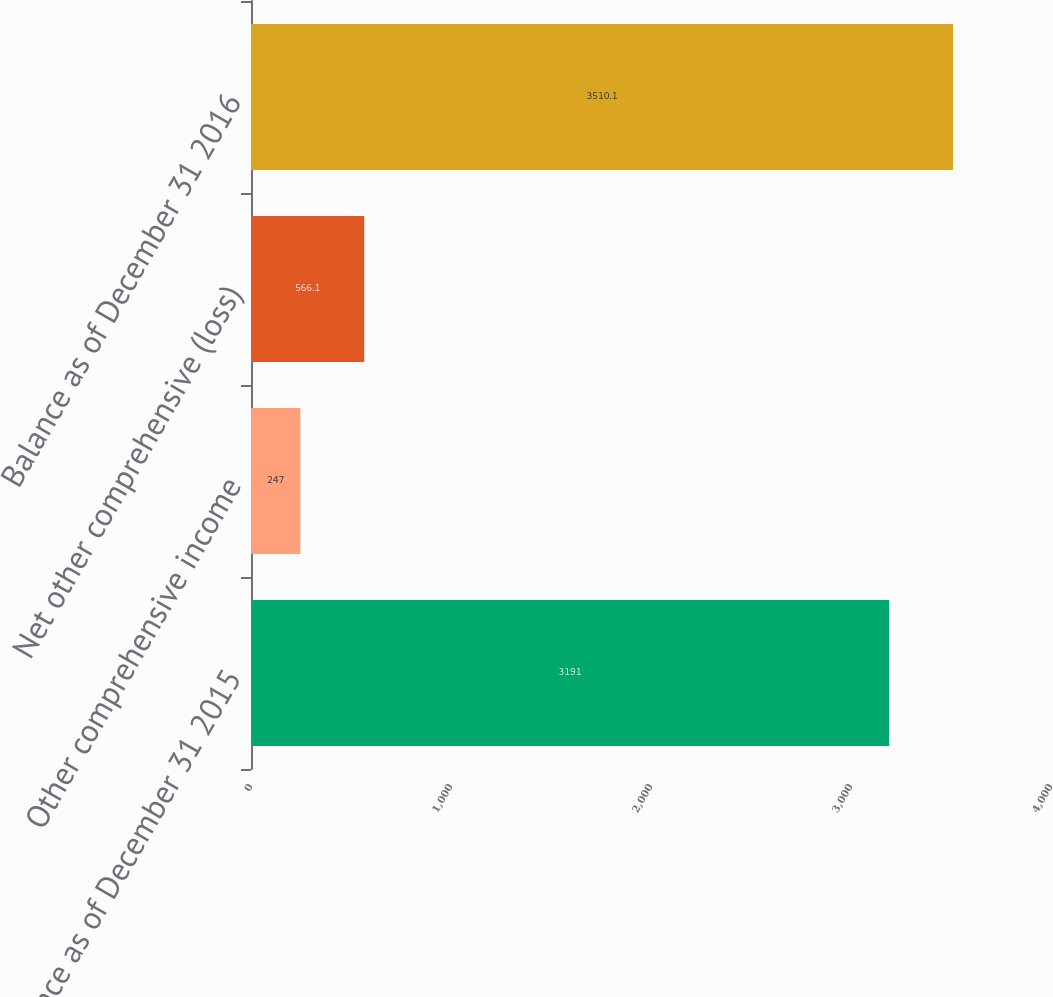Convert chart. <chart><loc_0><loc_0><loc_500><loc_500><bar_chart><fcel>Balance as of December 31 2015<fcel>Other comprehensive income<fcel>Net other comprehensive (loss)<fcel>Balance as of December 31 2016<nl><fcel>3191<fcel>247<fcel>566.1<fcel>3510.1<nl></chart> 